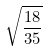Convert formula to latex. <formula><loc_0><loc_0><loc_500><loc_500>\sqrt { \frac { 1 8 } { 3 5 } }</formula> 